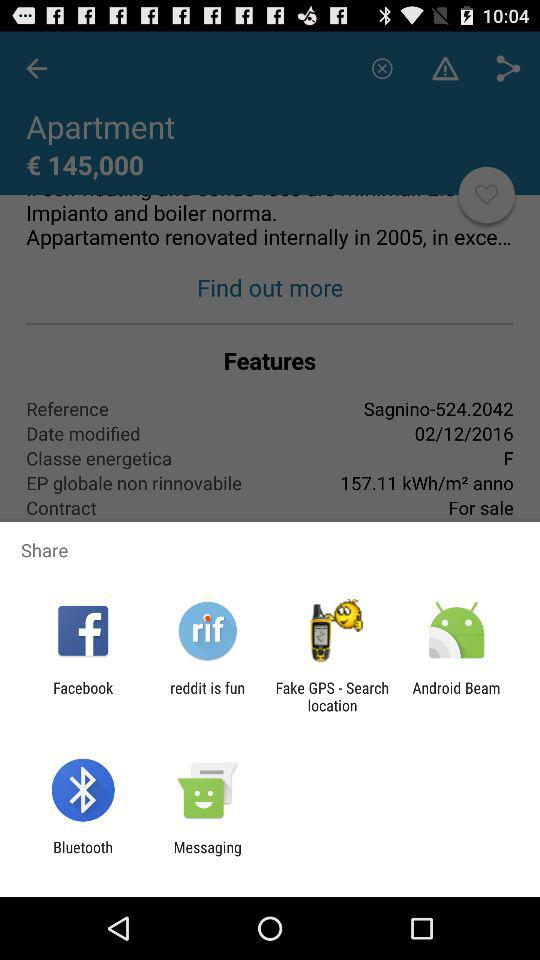What is the price of the apartment shown on the screen? The price is € 145,000. 